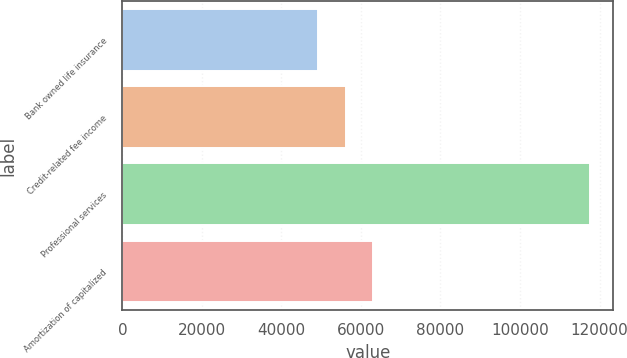Convert chart to OTSL. <chart><loc_0><loc_0><loc_500><loc_500><bar_chart><fcel>Bank owned life insurance<fcel>Credit-related fee income<fcel>Professional services<fcel>Amortization of capitalized<nl><fcel>49152<fcel>56150<fcel>117523<fcel>62987.1<nl></chart> 